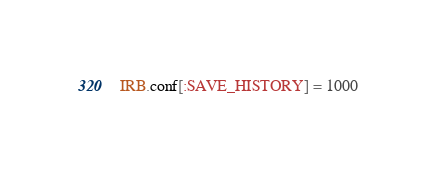Convert code to text. <code><loc_0><loc_0><loc_500><loc_500><_Ruby_>IRB.conf[:SAVE_HISTORY] = 1000
</code> 